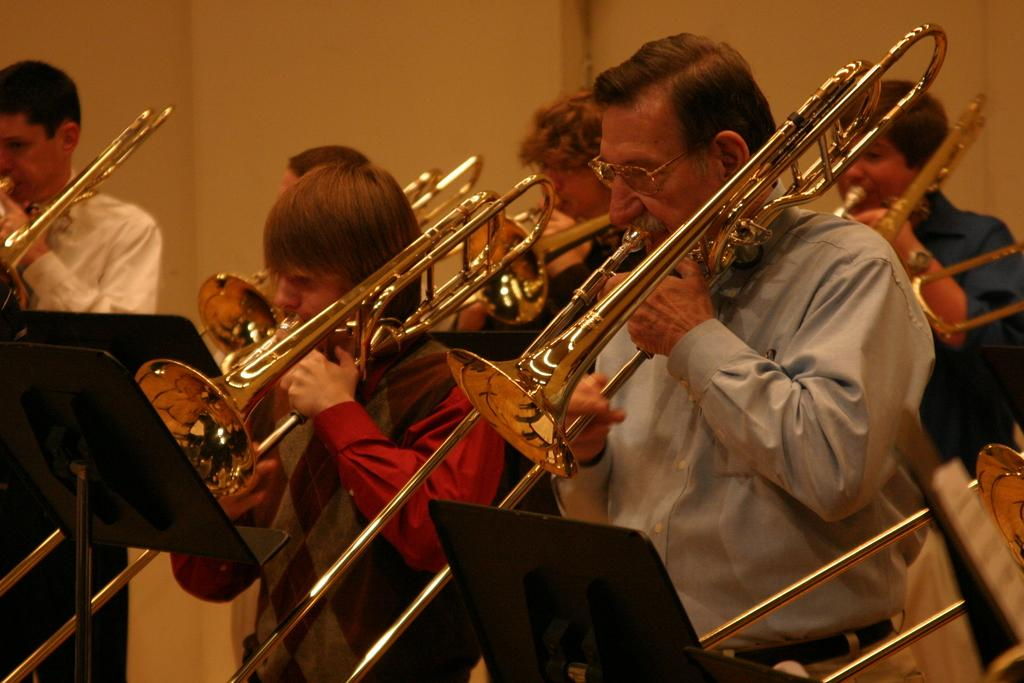What are the people in the image doing? The people in the image are playing musical instruments. What objects can be seen in the image besides the people? There are stands visible in the image. What is in the background of the image? There is a wall in the background of the image. What type of haircut does the secretary have in the image? There is no secretary present in the image, so it is not possible to answer that question. 